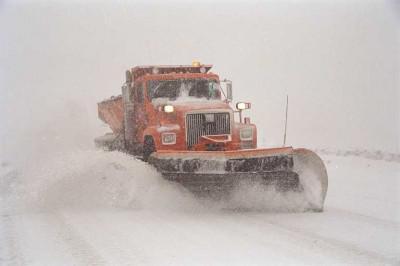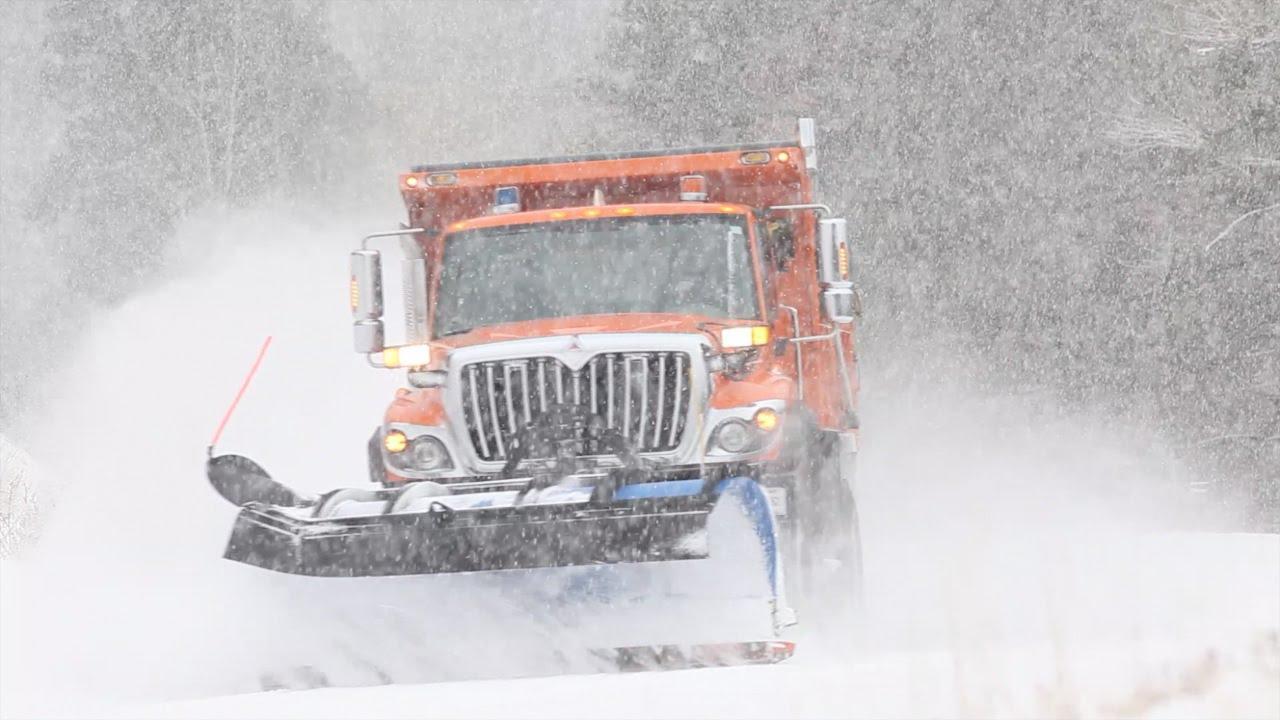The first image is the image on the left, the second image is the image on the right. Considering the images on both sides, is "In one of the images, the snow plow is not pushing snow." valid? Answer yes or no. No. 